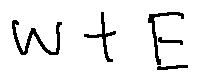<formula> <loc_0><loc_0><loc_500><loc_500>w + E</formula> 